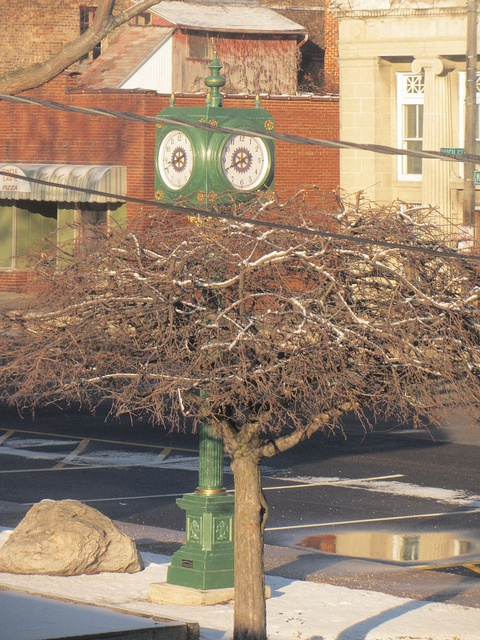Describe the objects in this image and their specific colors. I can see clock in tan, beige, and darkgray tones and clock in tan, ivory, and darkgray tones in this image. 